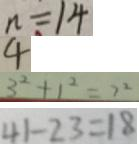<formula> <loc_0><loc_0><loc_500><loc_500>n = 1 4 
 4 
 3 ^ { 2 } + 1 ^ { 2 } = 7 ^ { 2 } 
 4 1 - 2 3 = 1 8</formula> 